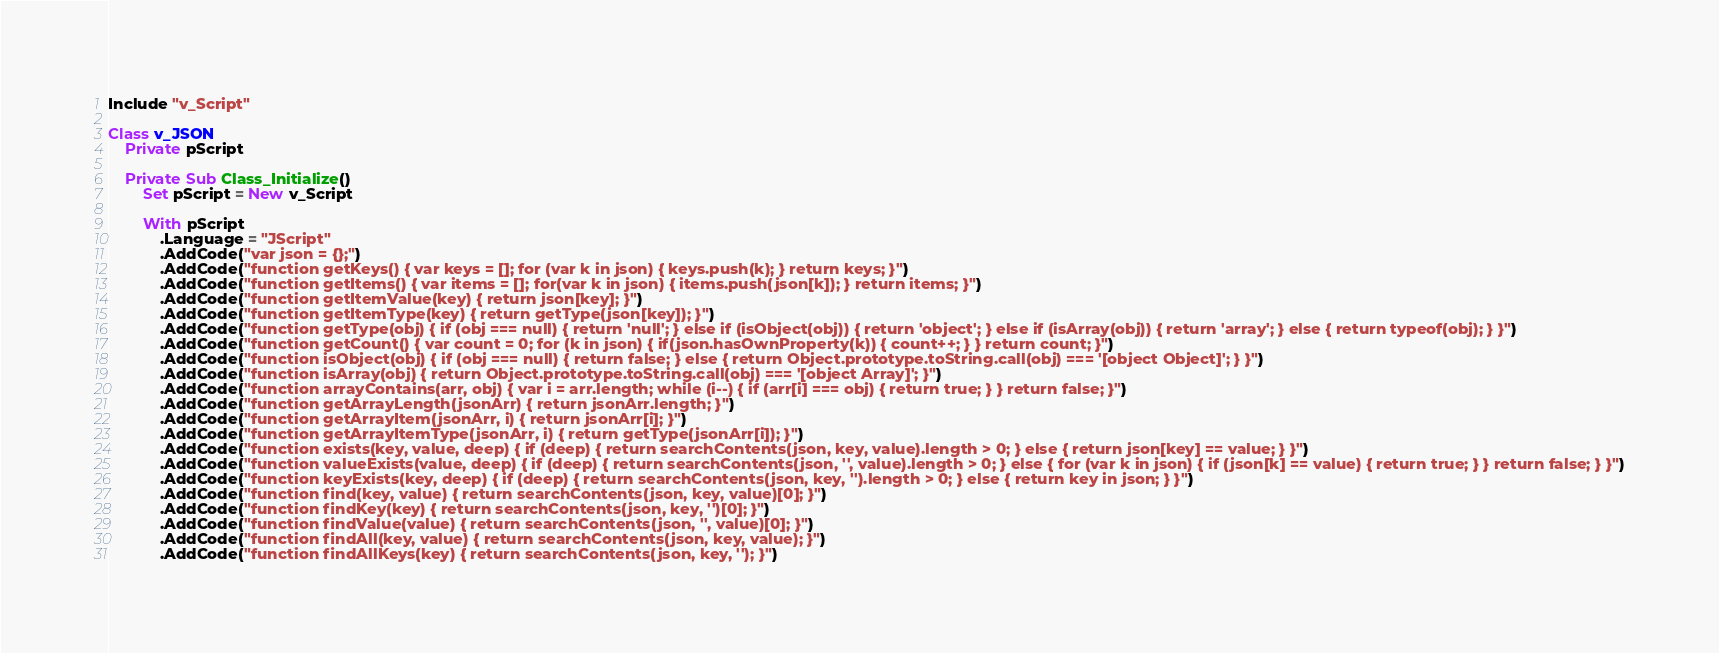<code> <loc_0><loc_0><loc_500><loc_500><_VisualBasic_>Include "v_Script"

Class v_JSON
	Private pScript

	Private Sub Class_Initialize()
		Set pScript = New v_Script

		With pScript
			.Language = "JScript"
			.AddCode("var json = {};")
			.AddCode("function getKeys() { var keys = []; for (var k in json) { keys.push(k); } return keys; }")
			.AddCode("function getItems() { var items = []; for(var k in json) { items.push(json[k]); } return items; }")
			.AddCode("function getItemValue(key) { return json[key]; }")
			.AddCode("function getItemType(key) { return getType(json[key]); }")
			.AddCode("function getType(obj) { if (obj === null) { return 'null'; } else if (isObject(obj)) { return 'object'; } else if (isArray(obj)) { return 'array'; } else { return typeof(obj); } }")
			.AddCode("function getCount() { var count = 0; for (k in json) { if(json.hasOwnProperty(k)) { count++; } } return count; }")
			.AddCode("function isObject(obj) { if (obj === null) { return false; } else { return Object.prototype.toString.call(obj) === '[object Object]'; } }")
			.AddCode("function isArray(obj) { return Object.prototype.toString.call(obj) === '[object Array]'; }")
			.AddCode("function arrayContains(arr, obj) { var i = arr.length; while (i--) { if (arr[i] === obj) { return true; } } return false; }")
			.AddCode("function getArrayLength(jsonArr) { return jsonArr.length; }")
			.AddCode("function getArrayItem(jsonArr, i) { return jsonArr[i]; }")
			.AddCode("function getArrayItemType(jsonArr, i) { return getType(jsonArr[i]); }")
			.AddCode("function exists(key, value, deep) { if (deep) { return searchContents(json, key, value).length > 0; } else { return json[key] == value; } }")
			.AddCode("function valueExists(value, deep) { if (deep) { return searchContents(json, '', value).length > 0; } else { for (var k in json) { if (json[k] == value) { return true; } } return false; } }")
			.AddCode("function keyExists(key, deep) { if (deep) { return searchContents(json, key, '').length > 0; } else { return key in json; } }")
			.AddCode("function find(key, value) { return searchContents(json, key, value)[0]; }")
			.AddCode("function findKey(key) { return searchContents(json, key, '')[0]; }")
			.AddCode("function findValue(value) { return searchContents(json, '', value)[0]; }")
			.AddCode("function findAll(key, value) { return searchContents(json, key, value); }")
			.AddCode("function findAllKeys(key) { return searchContents(json, key, ''); }")</code> 